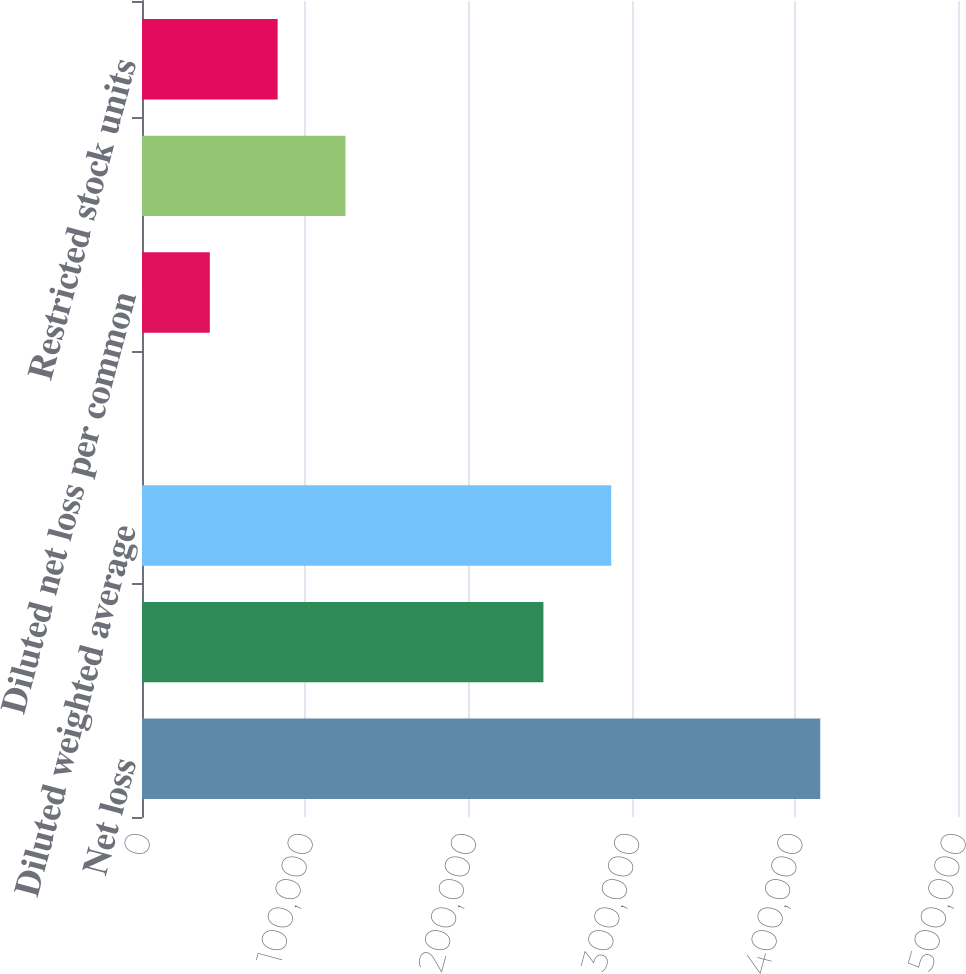Convert chart to OTSL. <chart><loc_0><loc_0><loc_500><loc_500><bar_chart><fcel>Net loss<fcel>Basic weighted average common<fcel>Diluted weighted average<fcel>Basic net loss per common<fcel>Diluted net loss per common<fcel>Outstanding stock options<fcel>Restricted stock units<nl><fcel>415588<fcel>245968<fcel>287527<fcel>1.69<fcel>41560.3<fcel>124678<fcel>83118.9<nl></chart> 